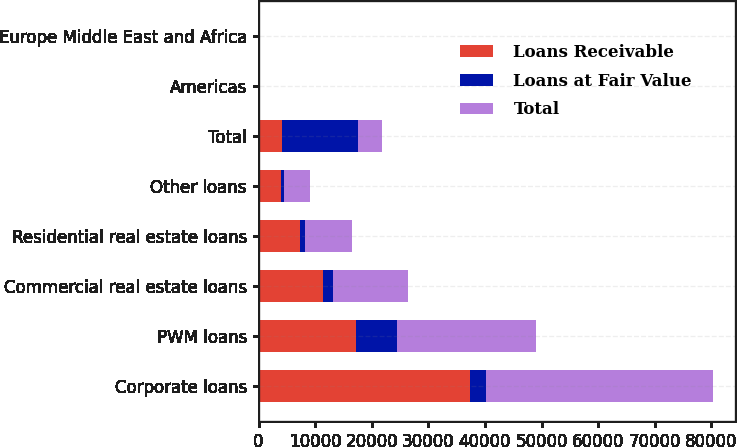Convert chart to OTSL. <chart><loc_0><loc_0><loc_500><loc_500><stacked_bar_chart><ecel><fcel>Corporate loans<fcel>PWM loans<fcel>Commercial real estate loans<fcel>Residential real estate loans<fcel>Other loans<fcel>Total<fcel>Americas<fcel>Europe Middle East and Africa<nl><fcel>Loans Receivable<fcel>37283<fcel>17219<fcel>11441<fcel>7284<fcel>3893<fcel>4221<fcel>67<fcel>16<nl><fcel>Loans at Fair Value<fcel>2819<fcel>7250<fcel>1718<fcel>973<fcel>656<fcel>13416<fcel>11<fcel>2<nl><fcel>Total<fcel>40102<fcel>24469<fcel>13159<fcel>8257<fcel>4549<fcel>4221<fcel>78<fcel>18<nl></chart> 